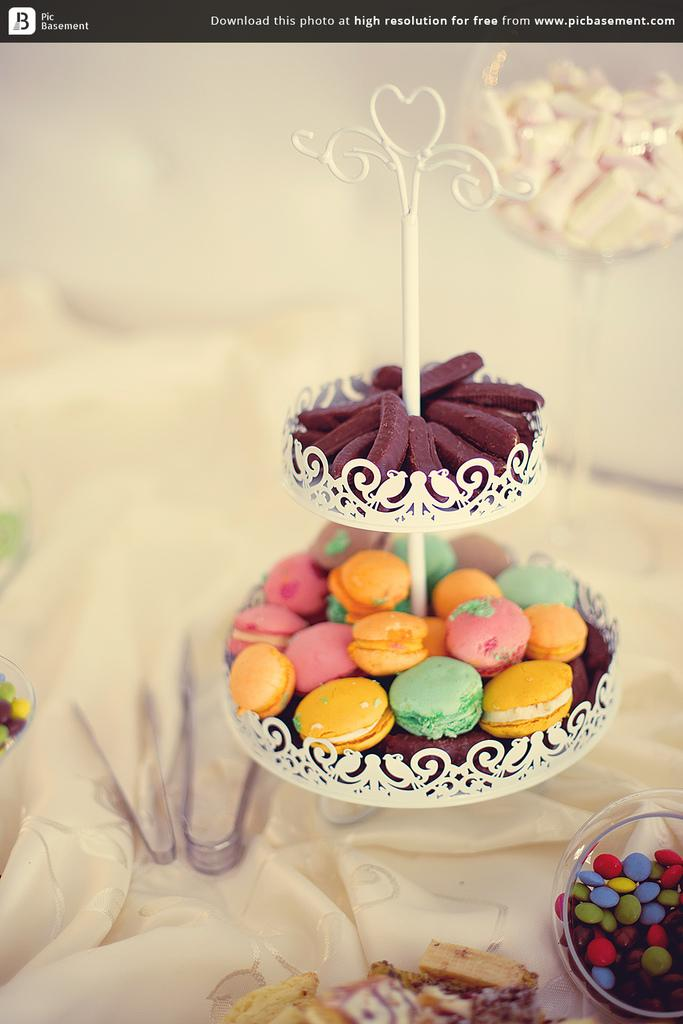What types of sweets can be seen in the image? There are candies in different bowls in the image. What tools are present in the image? There are two forceps in the image. Can you read any text in the image? There is text visible at the top of the image. What type of clouds can be seen in the image? There are no clouds present in the image. How many eyes are visible in the image? There are no eyes visible in the image. 